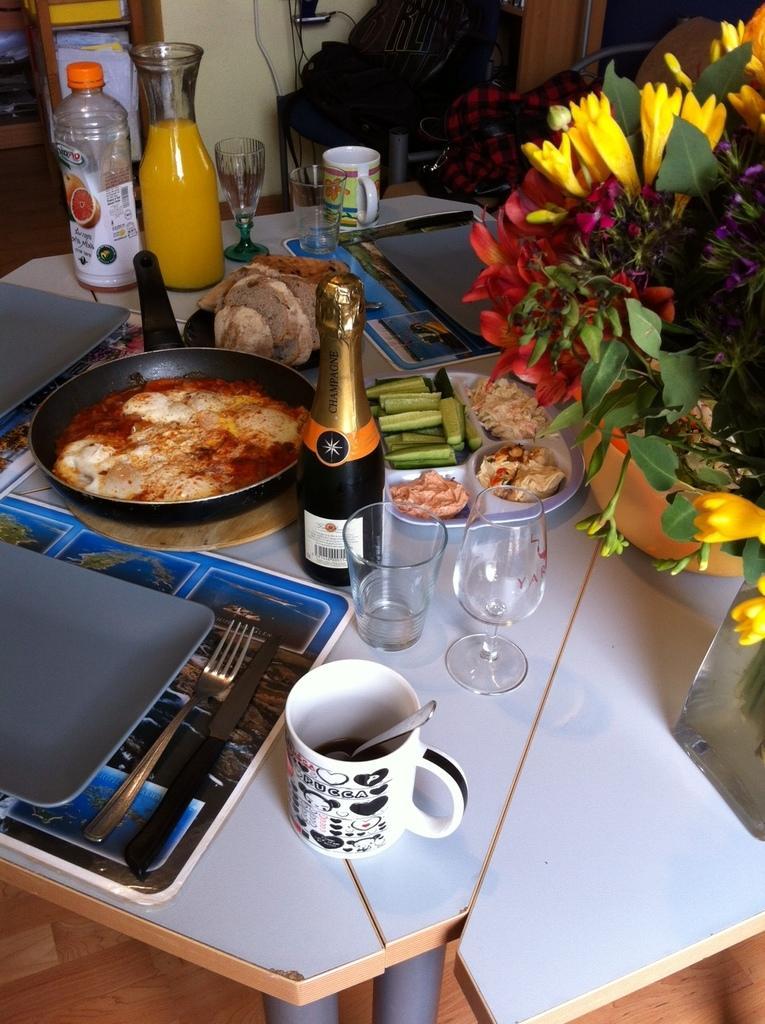Please provide a concise description of this image. Here there is a table on which there are some food items, glasses, bottles and a pan and also flowers and small plant. 